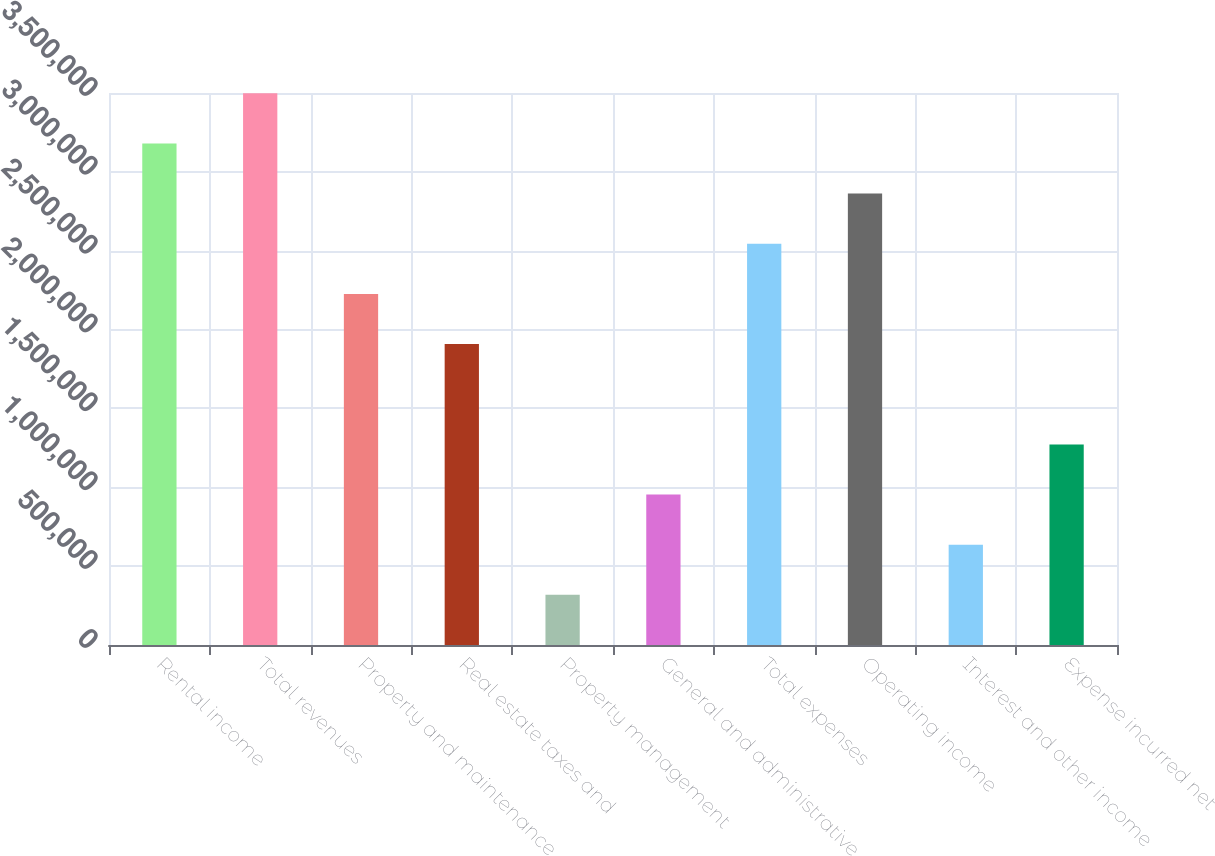Convert chart. <chart><loc_0><loc_0><loc_500><loc_500><bar_chart><fcel>Rental income<fcel>Total revenues<fcel>Property and maintenance<fcel>Real estate taxes and<fcel>Property management<fcel>General and administrative<fcel>Total expenses<fcel>Operating income<fcel>Interest and other income<fcel>Expense incurred net<nl><fcel>3.18004e+06<fcel>3.49804e+06<fcel>2.22603e+06<fcel>1.90802e+06<fcel>318005<fcel>954013<fcel>2.54403e+06<fcel>2.86204e+06<fcel>636009<fcel>1.27202e+06<nl></chart> 